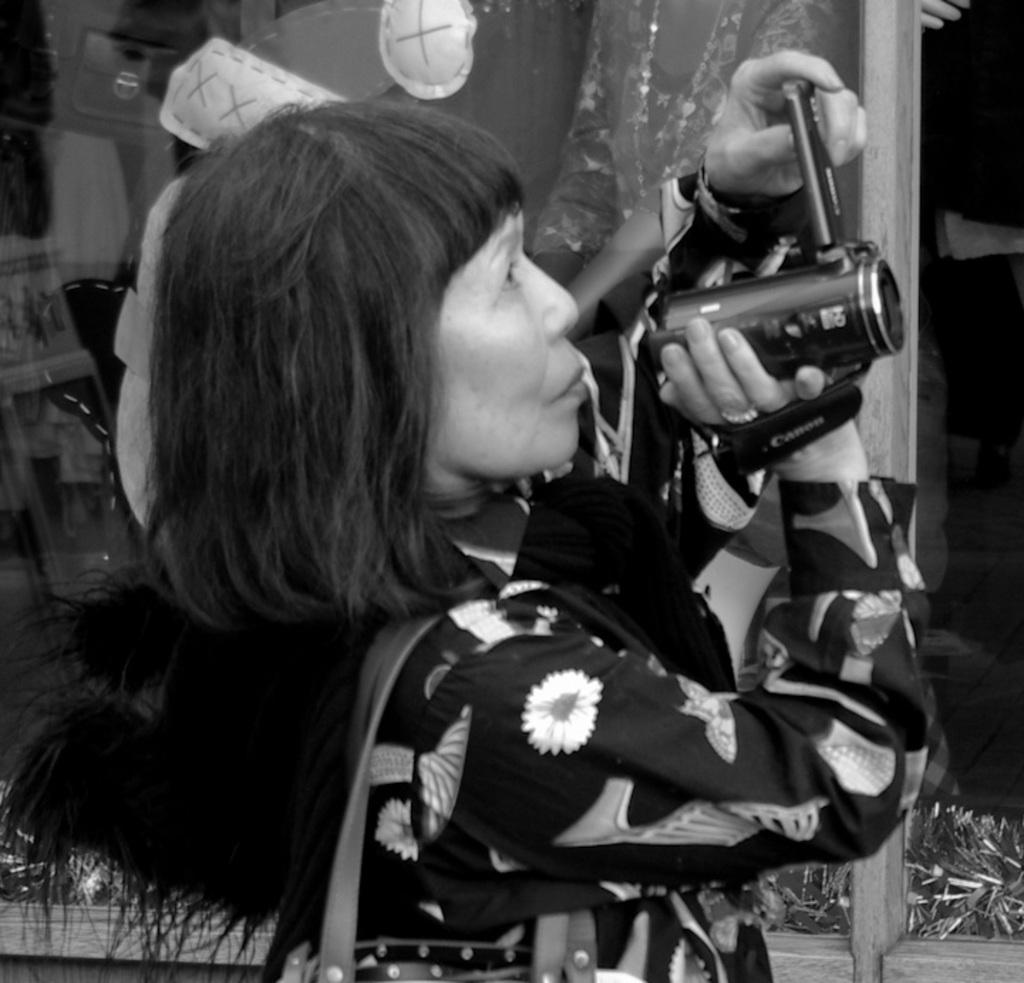Describe this image in one or two sentences. There is a woman standing and holding the camera capturing something and on the other side there is a glass wall. 